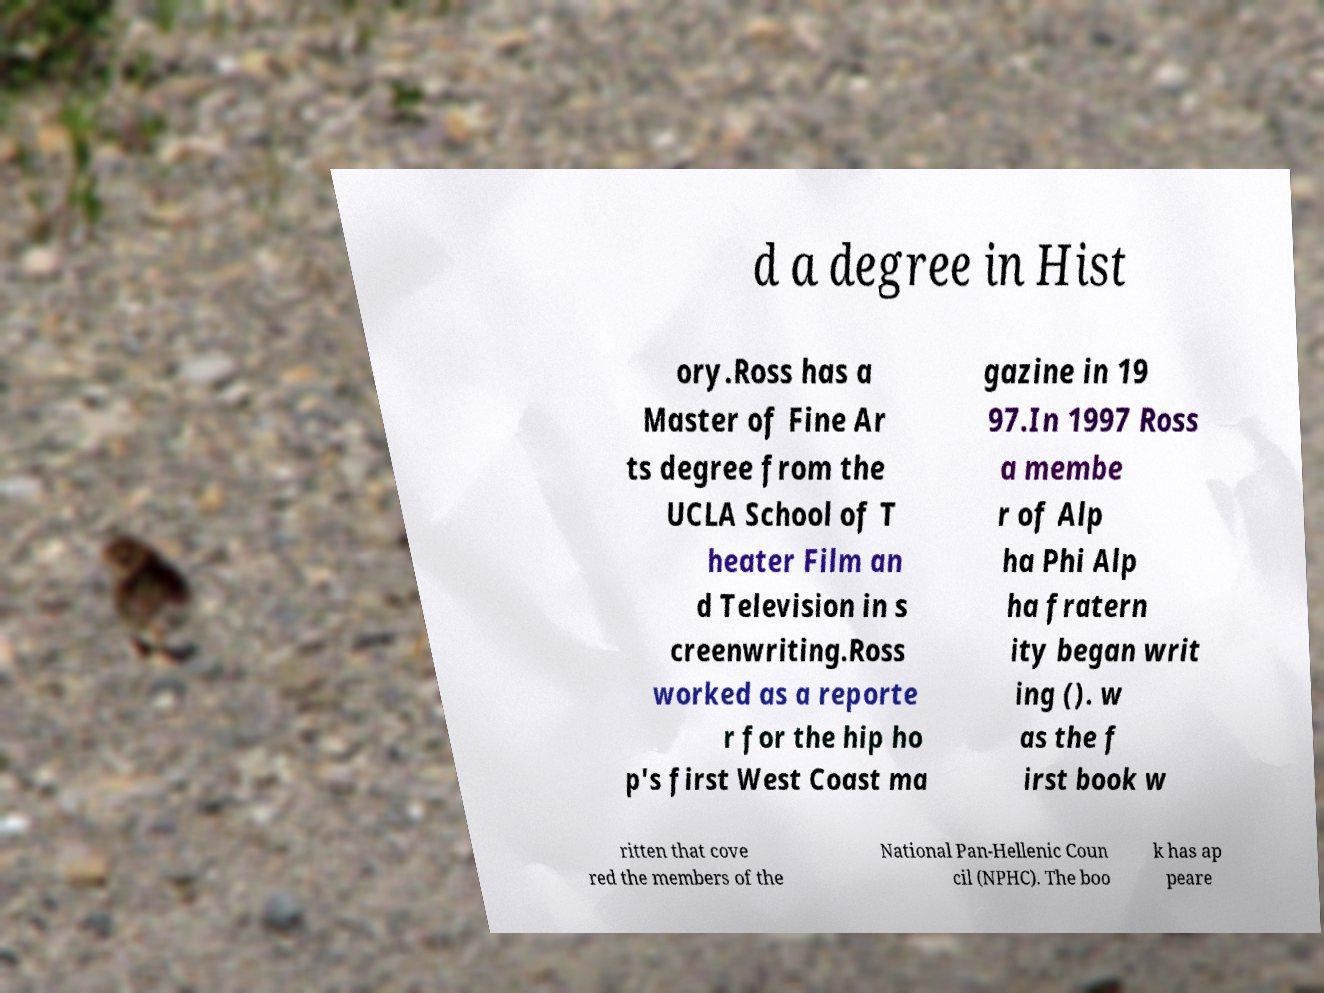Could you assist in decoding the text presented in this image and type it out clearly? d a degree in Hist ory.Ross has a Master of Fine Ar ts degree from the UCLA School of T heater Film an d Television in s creenwriting.Ross worked as a reporte r for the hip ho p's first West Coast ma gazine in 19 97.In 1997 Ross a membe r of Alp ha Phi Alp ha fratern ity began writ ing (). w as the f irst book w ritten that cove red the members of the National Pan-Hellenic Coun cil (NPHC). The boo k has ap peare 